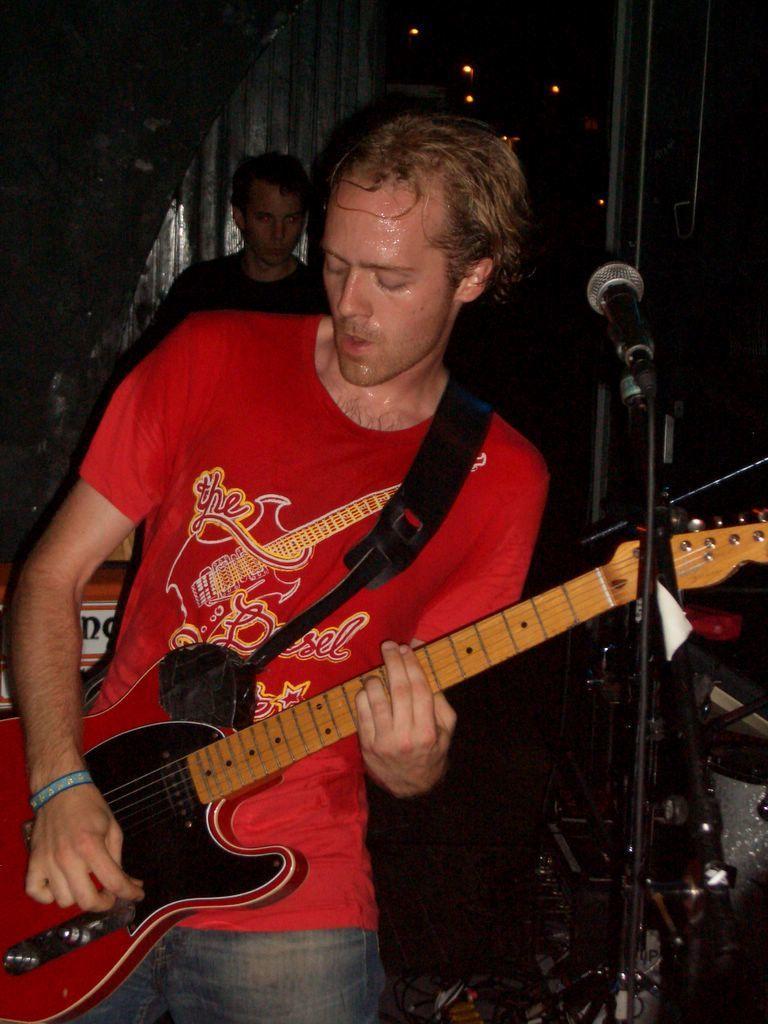Could you give a brief overview of what you see in this image? In the image we can see there is a person who is standing and holding guitar in the hand. 